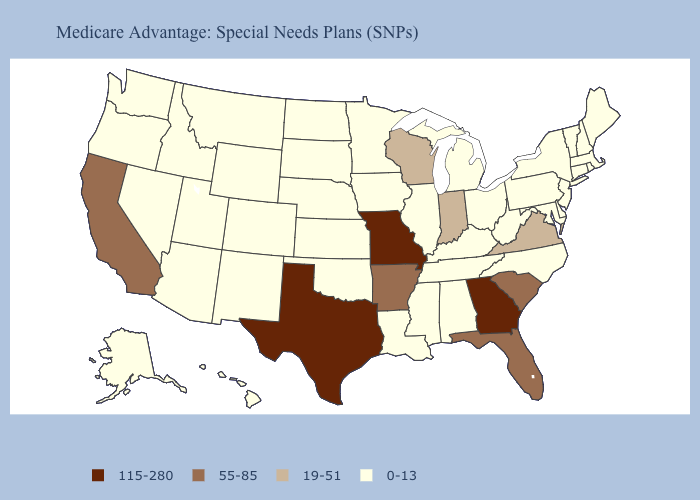Which states hav the highest value in the Northeast?
Keep it brief. Connecticut, Massachusetts, Maine, New Hampshire, New Jersey, New York, Pennsylvania, Rhode Island, Vermont. What is the lowest value in states that border Ohio?
Write a very short answer. 0-13. Which states have the highest value in the USA?
Short answer required. Georgia, Missouri, Texas. Does New Jersey have the same value as Louisiana?
Give a very brief answer. Yes. What is the lowest value in the USA?
Keep it brief. 0-13. Which states have the highest value in the USA?
Concise answer only. Georgia, Missouri, Texas. What is the value of New Hampshire?
Be succinct. 0-13. Which states hav the highest value in the Northeast?
Short answer required. Connecticut, Massachusetts, Maine, New Hampshire, New Jersey, New York, Pennsylvania, Rhode Island, Vermont. Does Iowa have the highest value in the MidWest?
Keep it brief. No. What is the value of Louisiana?
Short answer required. 0-13. What is the highest value in the MidWest ?
Quick response, please. 115-280. Name the states that have a value in the range 0-13?
Concise answer only. Alaska, Alabama, Arizona, Colorado, Connecticut, Delaware, Hawaii, Iowa, Idaho, Illinois, Kansas, Kentucky, Louisiana, Massachusetts, Maryland, Maine, Michigan, Minnesota, Mississippi, Montana, North Carolina, North Dakota, Nebraska, New Hampshire, New Jersey, New Mexico, Nevada, New York, Ohio, Oklahoma, Oregon, Pennsylvania, Rhode Island, South Dakota, Tennessee, Utah, Vermont, Washington, West Virginia, Wyoming. Name the states that have a value in the range 19-51?
Give a very brief answer. Indiana, Virginia, Wisconsin. Which states have the highest value in the USA?
Give a very brief answer. Georgia, Missouri, Texas. Name the states that have a value in the range 55-85?
Short answer required. Arkansas, California, Florida, South Carolina. 